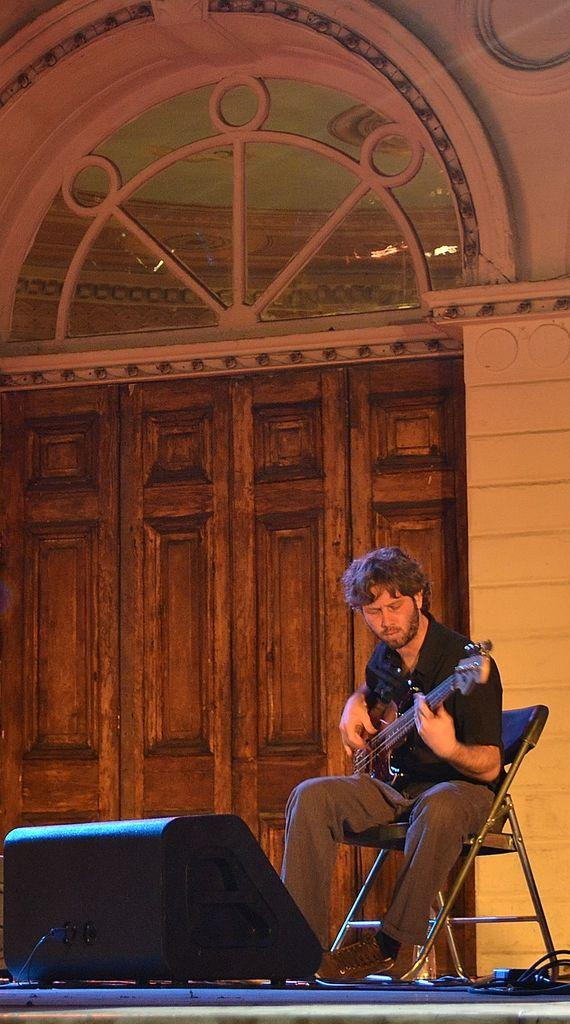What is the person in the image doing? The person is sitting on a chair and holding a guitar. What can be seen in the background of the image? There is a wall and a door in the background of the image. What type of crate is being used to care for the parent in the image? There is no crate or parent present in the image; it features a person sitting on a chair and holding a guitar. 